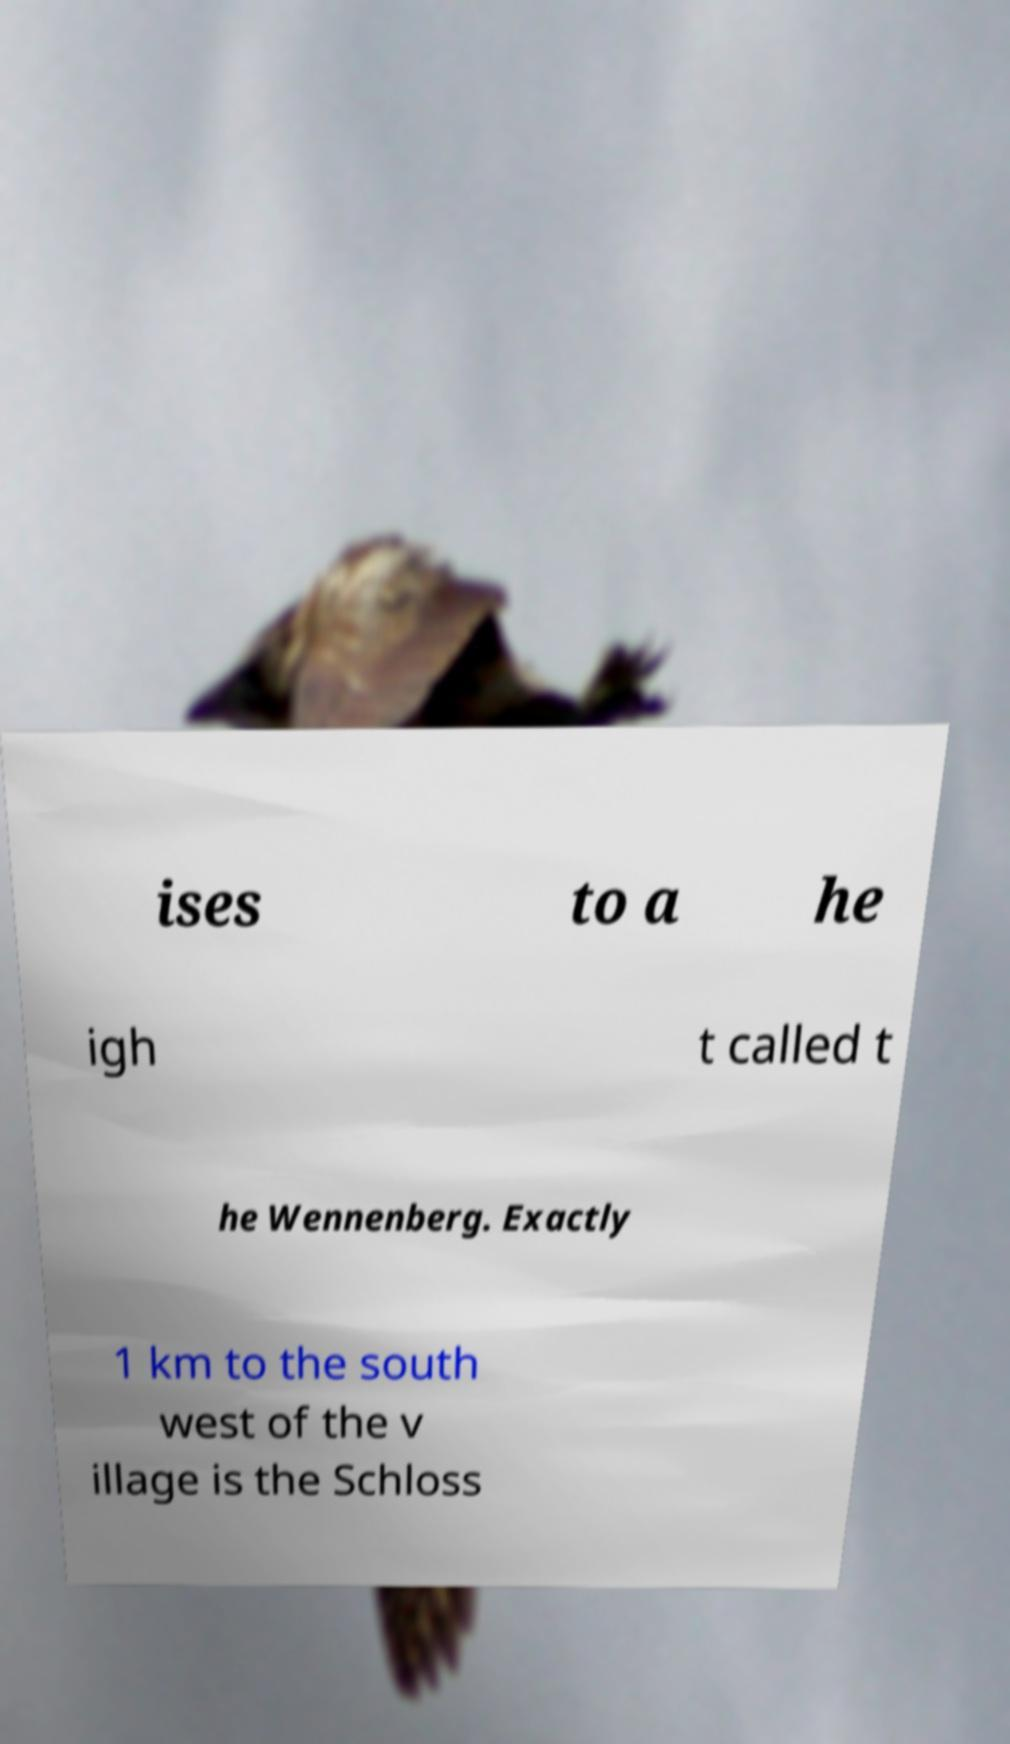For documentation purposes, I need the text within this image transcribed. Could you provide that? ises to a he igh t called t he Wennenberg. Exactly 1 km to the south west of the v illage is the Schloss 